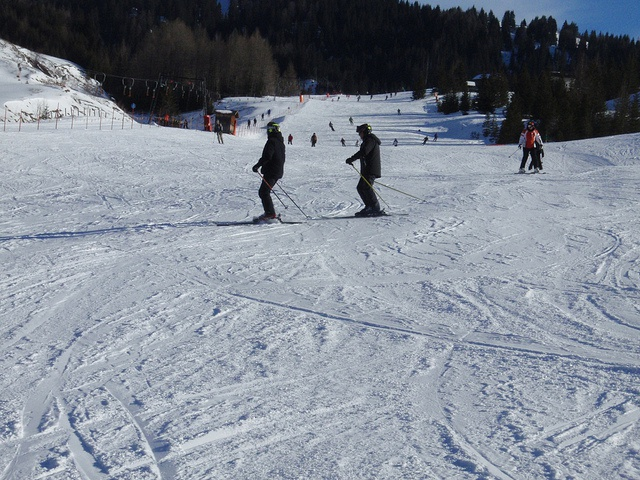Describe the objects in this image and their specific colors. I can see people in black, gray, and darkgray tones, people in black, gray, and darkgray tones, people in black, maroon, and gray tones, skis in black, darkgray, and gray tones, and people in black, gray, and darkgray tones in this image. 